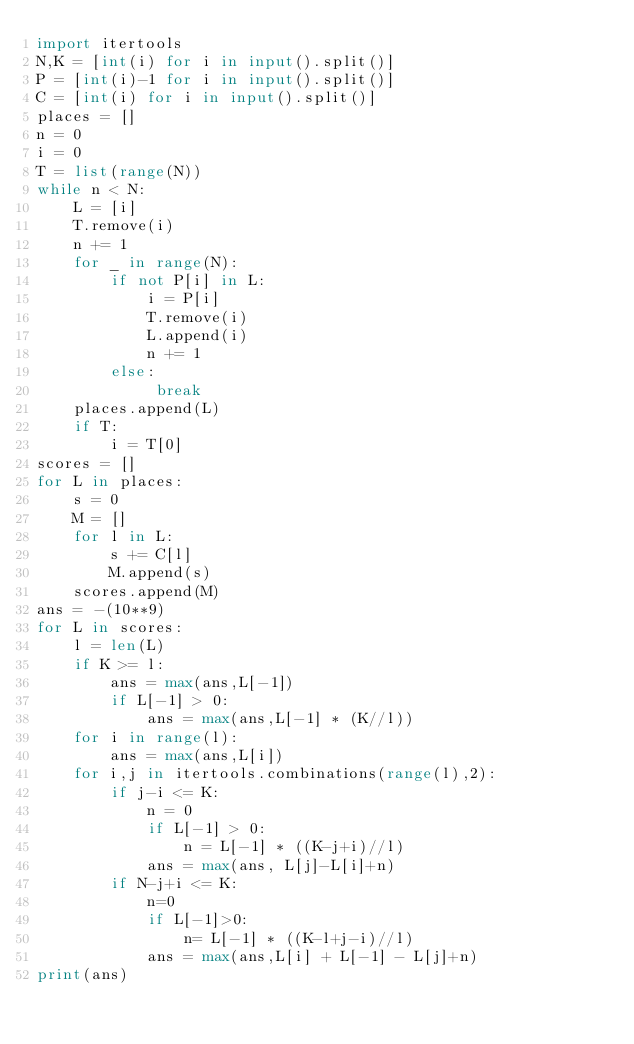<code> <loc_0><loc_0><loc_500><loc_500><_Python_>import itertools
N,K = [int(i) for i in input().split()]
P = [int(i)-1 for i in input().split()]
C = [int(i) for i in input().split()]
places = []
n = 0
i = 0
T = list(range(N))
while n < N:
    L = [i]
    T.remove(i)
    n += 1
    for _ in range(N):
        if not P[i] in L:
            i = P[i]
            T.remove(i)
            L.append(i)
            n += 1
        else:
             break
    places.append(L)
    if T:
        i = T[0]
scores = []
for L in places:
    s = 0
    M = []
    for l in L:
        s += C[l]
        M.append(s)
    scores.append(M)
ans = -(10**9)
for L in scores:
    l = len(L)
    if K >= l:
        ans = max(ans,L[-1])
        if L[-1] > 0:
            ans = max(ans,L[-1] * (K//l))
    for i in range(l):
        ans = max(ans,L[i])
    for i,j in itertools.combinations(range(l),2):
        if j-i <= K:
            n = 0
            if L[-1] > 0:
                n = L[-1] * ((K-j+i)//l)
            ans = max(ans, L[j]-L[i]+n)
        if N-j+i <= K:
            n=0
            if L[-1]>0:
                n= L[-1] * ((K-l+j-i)//l)
            ans = max(ans,L[i] + L[-1] - L[j]+n)
print(ans)</code> 